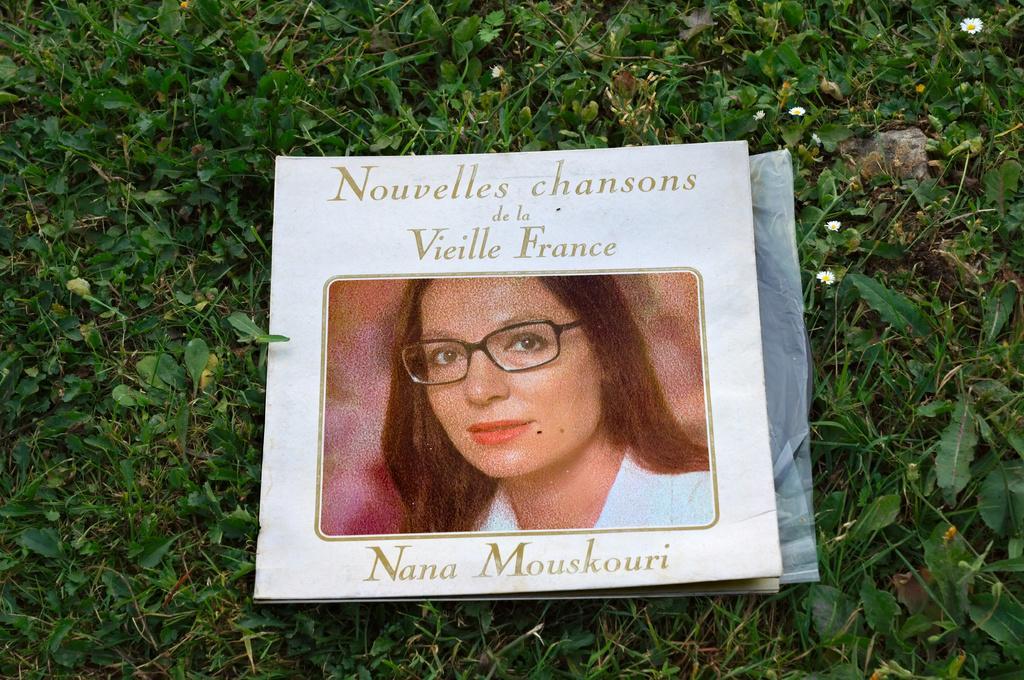Describe this image in one or two sentences. In the picture I can see a paper which has a photo of a woman and something written on it. I can also see flower plants. These flowers are white in color. 